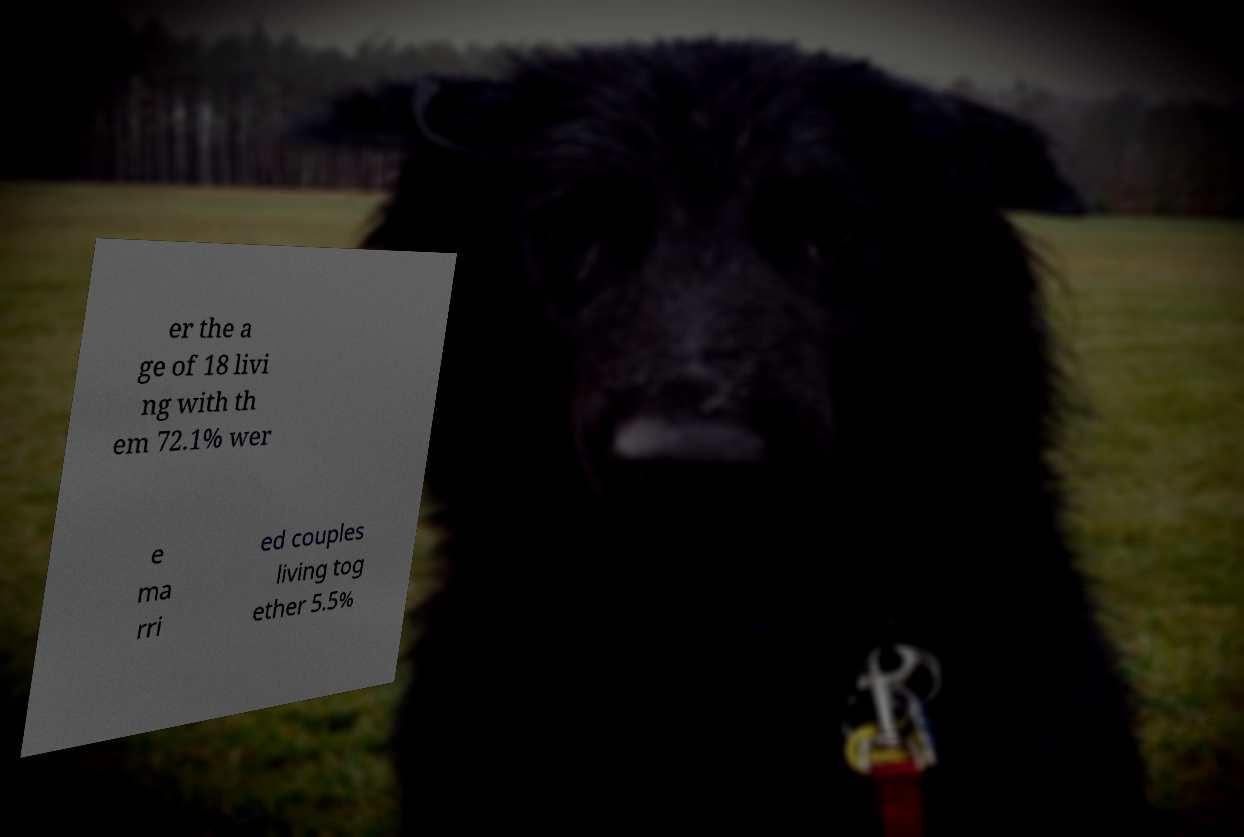Could you assist in decoding the text presented in this image and type it out clearly? er the a ge of 18 livi ng with th em 72.1% wer e ma rri ed couples living tog ether 5.5% 